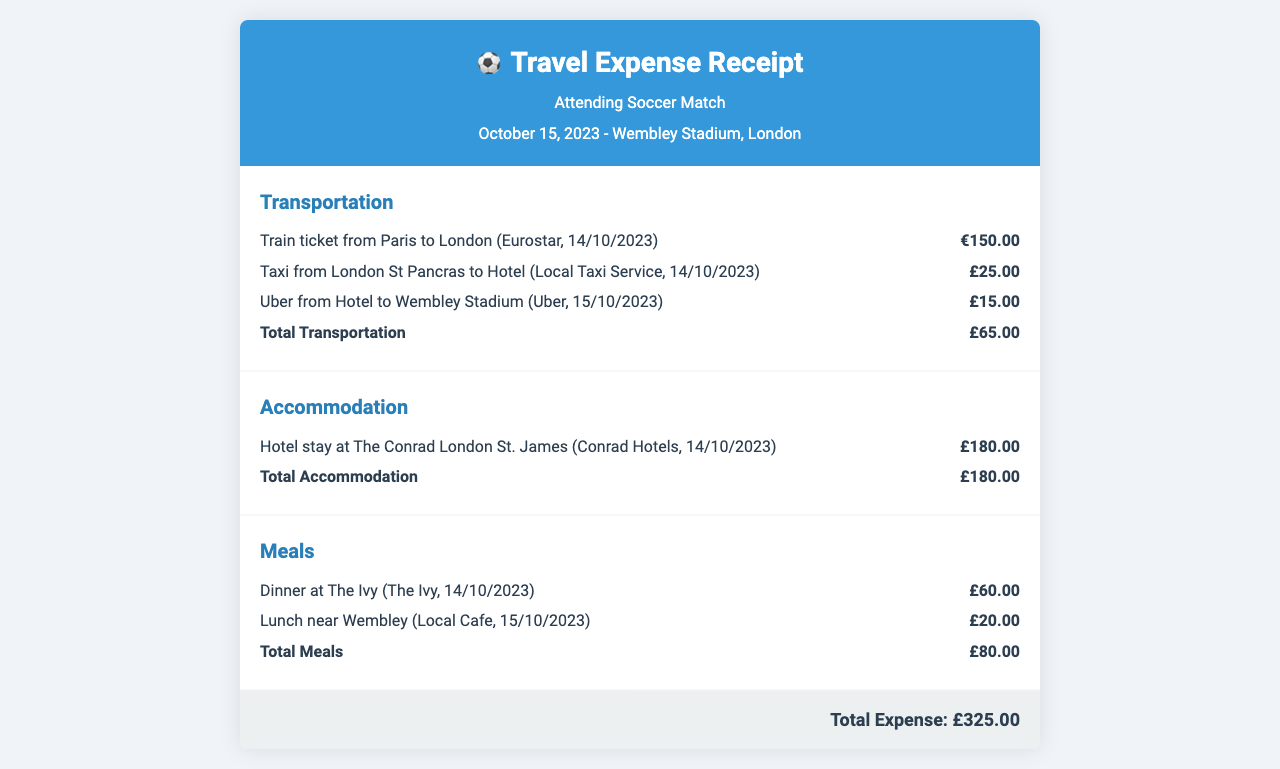What is the date of the soccer match? The date of the soccer match is stated in the document as October 15, 2023.
Answer: October 15, 2023 What is the total amount spent on meals? The total spent on meals is provided in the document as the sum of the meal expenses, which totals £80.00.
Answer: £80.00 What type of transportation was used from Paris to London? The document specifies that a train ticket was used for the travel from Paris to London.
Answer: Train How much did the hotel stay cost? The document lists the cost of housing at The Conrad London St. James as £180.00.
Answer: £180.00 What is the total travel expense? The total travel expense is summed up at the end of the document, amounting to £325.00.
Answer: £325.00 Which taxi service was used in London? The document notes that a local taxi service was utilized for transportation from London St Pancras to the hotel.
Answer: Local Taxi Service What city was the soccer match held in? According to the document, the soccer match took place in London at Wembley Stadium.
Answer: London How much was spent on the Uber ride? The document indicates that the Uber ride from the hotel to Wembley Stadium cost £15.00.
Answer: £15.00 What was the meal expense for lunch near Wembley? The meal expense for lunch near Wembley is indicated as £20.00 in the document.
Answer: £20.00 